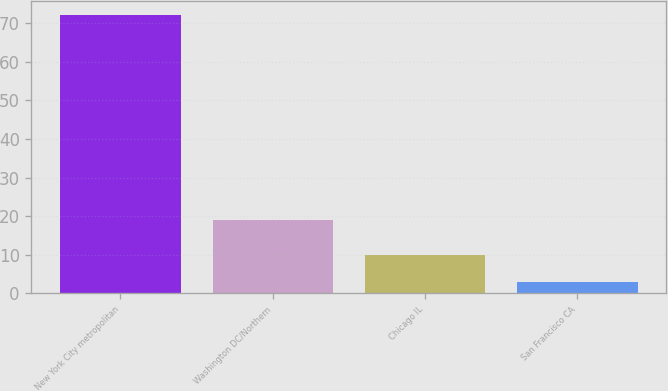Convert chart to OTSL. <chart><loc_0><loc_0><loc_500><loc_500><bar_chart><fcel>New York City metropolitan<fcel>Washington DC/Northern<fcel>Chicago IL<fcel>San Francisco CA<nl><fcel>72<fcel>19<fcel>9.9<fcel>3<nl></chart> 